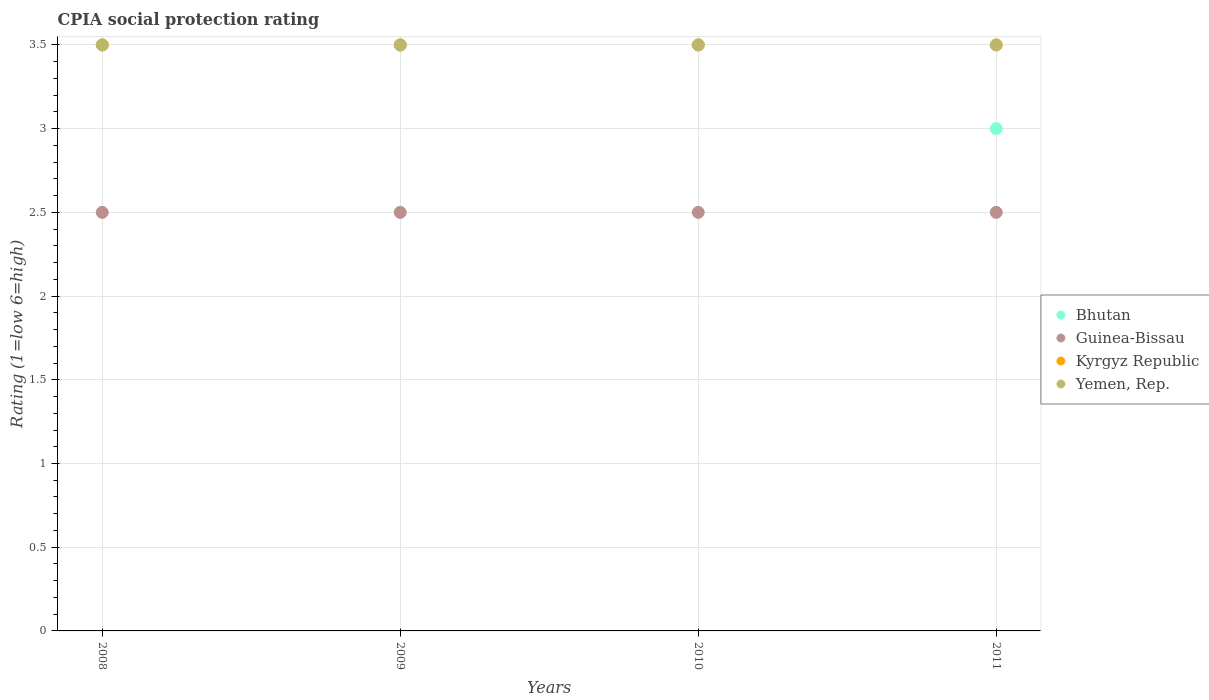How many different coloured dotlines are there?
Ensure brevity in your answer.  4. Is the number of dotlines equal to the number of legend labels?
Your answer should be compact. Yes. What is the CPIA rating in Yemen, Rep. in 2010?
Offer a very short reply. 3.5. Across all years, what is the maximum CPIA rating in Yemen, Rep.?
Your response must be concise. 3.5. In which year was the CPIA rating in Guinea-Bissau maximum?
Your answer should be compact. 2008. In which year was the CPIA rating in Bhutan minimum?
Give a very brief answer. 2011. What is the total CPIA rating in Kyrgyz Republic in the graph?
Offer a very short reply. 14. What is the average CPIA rating in Bhutan per year?
Provide a short and direct response. 3.38. What is the ratio of the CPIA rating in Yemen, Rep. in 2008 to that in 2010?
Offer a very short reply. 1. What is the difference between the highest and the second highest CPIA rating in Yemen, Rep.?
Your answer should be very brief. 0. What is the difference between the highest and the lowest CPIA rating in Yemen, Rep.?
Your response must be concise. 0. Is it the case that in every year, the sum of the CPIA rating in Guinea-Bissau and CPIA rating in Bhutan  is greater than the CPIA rating in Kyrgyz Republic?
Ensure brevity in your answer.  Yes. Does the CPIA rating in Yemen, Rep. monotonically increase over the years?
Offer a very short reply. No. Is the CPIA rating in Guinea-Bissau strictly greater than the CPIA rating in Yemen, Rep. over the years?
Make the answer very short. No. Is the CPIA rating in Bhutan strictly less than the CPIA rating in Guinea-Bissau over the years?
Offer a very short reply. No. How many dotlines are there?
Ensure brevity in your answer.  4. How many years are there in the graph?
Your response must be concise. 4. Does the graph contain any zero values?
Keep it short and to the point. No. Does the graph contain grids?
Make the answer very short. Yes. How many legend labels are there?
Make the answer very short. 4. What is the title of the graph?
Your response must be concise. CPIA social protection rating. What is the label or title of the X-axis?
Your response must be concise. Years. What is the label or title of the Y-axis?
Provide a short and direct response. Rating (1=low 6=high). What is the Rating (1=low 6=high) of Bhutan in 2008?
Offer a very short reply. 3.5. What is the Rating (1=low 6=high) in Bhutan in 2009?
Offer a very short reply. 3.5. What is the Rating (1=low 6=high) of Guinea-Bissau in 2009?
Make the answer very short. 2.5. What is the Rating (1=low 6=high) of Yemen, Rep. in 2009?
Keep it short and to the point. 3.5. What is the Rating (1=low 6=high) of Bhutan in 2010?
Provide a short and direct response. 3.5. What is the Rating (1=low 6=high) of Guinea-Bissau in 2010?
Your answer should be compact. 2.5. What is the Rating (1=low 6=high) of Kyrgyz Republic in 2010?
Ensure brevity in your answer.  3.5. What is the Rating (1=low 6=high) of Bhutan in 2011?
Offer a very short reply. 3. What is the Rating (1=low 6=high) of Yemen, Rep. in 2011?
Offer a very short reply. 3.5. Across all years, what is the maximum Rating (1=low 6=high) of Guinea-Bissau?
Keep it short and to the point. 2.5. Across all years, what is the maximum Rating (1=low 6=high) in Kyrgyz Republic?
Your answer should be compact. 3.5. Across all years, what is the minimum Rating (1=low 6=high) of Kyrgyz Republic?
Your answer should be compact. 3.5. Across all years, what is the minimum Rating (1=low 6=high) of Yemen, Rep.?
Provide a short and direct response. 3.5. What is the total Rating (1=low 6=high) of Bhutan in the graph?
Keep it short and to the point. 13.5. What is the total Rating (1=low 6=high) of Kyrgyz Republic in the graph?
Provide a succinct answer. 14. What is the total Rating (1=low 6=high) of Yemen, Rep. in the graph?
Your answer should be very brief. 14. What is the difference between the Rating (1=low 6=high) in Guinea-Bissau in 2008 and that in 2009?
Provide a succinct answer. 0. What is the difference between the Rating (1=low 6=high) in Yemen, Rep. in 2008 and that in 2009?
Give a very brief answer. 0. What is the difference between the Rating (1=low 6=high) of Guinea-Bissau in 2008 and that in 2010?
Offer a very short reply. 0. What is the difference between the Rating (1=low 6=high) in Kyrgyz Republic in 2008 and that in 2010?
Provide a short and direct response. 0. What is the difference between the Rating (1=low 6=high) in Yemen, Rep. in 2008 and that in 2010?
Offer a very short reply. 0. What is the difference between the Rating (1=low 6=high) of Bhutan in 2008 and that in 2011?
Make the answer very short. 0.5. What is the difference between the Rating (1=low 6=high) in Yemen, Rep. in 2008 and that in 2011?
Provide a succinct answer. 0. What is the difference between the Rating (1=low 6=high) of Guinea-Bissau in 2009 and that in 2010?
Offer a very short reply. 0. What is the difference between the Rating (1=low 6=high) of Kyrgyz Republic in 2009 and that in 2010?
Your response must be concise. 0. What is the difference between the Rating (1=low 6=high) of Yemen, Rep. in 2009 and that in 2010?
Your answer should be very brief. 0. What is the difference between the Rating (1=low 6=high) in Guinea-Bissau in 2009 and that in 2011?
Offer a very short reply. 0. What is the difference between the Rating (1=low 6=high) in Kyrgyz Republic in 2009 and that in 2011?
Your answer should be very brief. 0. What is the difference between the Rating (1=low 6=high) in Bhutan in 2010 and that in 2011?
Your response must be concise. 0.5. What is the difference between the Rating (1=low 6=high) in Guinea-Bissau in 2010 and that in 2011?
Provide a short and direct response. 0. What is the difference between the Rating (1=low 6=high) of Yemen, Rep. in 2010 and that in 2011?
Give a very brief answer. 0. What is the difference between the Rating (1=low 6=high) of Bhutan in 2008 and the Rating (1=low 6=high) of Guinea-Bissau in 2009?
Your answer should be compact. 1. What is the difference between the Rating (1=low 6=high) of Bhutan in 2008 and the Rating (1=low 6=high) of Yemen, Rep. in 2009?
Offer a terse response. 0. What is the difference between the Rating (1=low 6=high) of Guinea-Bissau in 2008 and the Rating (1=low 6=high) of Kyrgyz Republic in 2009?
Make the answer very short. -1. What is the difference between the Rating (1=low 6=high) of Guinea-Bissau in 2008 and the Rating (1=low 6=high) of Yemen, Rep. in 2009?
Ensure brevity in your answer.  -1. What is the difference between the Rating (1=low 6=high) in Kyrgyz Republic in 2008 and the Rating (1=low 6=high) in Yemen, Rep. in 2009?
Provide a succinct answer. 0. What is the difference between the Rating (1=low 6=high) in Bhutan in 2008 and the Rating (1=low 6=high) in Kyrgyz Republic in 2010?
Keep it short and to the point. 0. What is the difference between the Rating (1=low 6=high) in Guinea-Bissau in 2008 and the Rating (1=low 6=high) in Yemen, Rep. in 2010?
Offer a very short reply. -1. What is the difference between the Rating (1=low 6=high) in Kyrgyz Republic in 2008 and the Rating (1=low 6=high) in Yemen, Rep. in 2010?
Ensure brevity in your answer.  0. What is the difference between the Rating (1=low 6=high) of Bhutan in 2008 and the Rating (1=low 6=high) of Yemen, Rep. in 2011?
Give a very brief answer. 0. What is the difference between the Rating (1=low 6=high) of Bhutan in 2009 and the Rating (1=low 6=high) of Guinea-Bissau in 2010?
Make the answer very short. 1. What is the difference between the Rating (1=low 6=high) in Kyrgyz Republic in 2009 and the Rating (1=low 6=high) in Yemen, Rep. in 2010?
Your answer should be compact. 0. What is the difference between the Rating (1=low 6=high) of Bhutan in 2009 and the Rating (1=low 6=high) of Guinea-Bissau in 2011?
Your answer should be very brief. 1. What is the difference between the Rating (1=low 6=high) in Bhutan in 2009 and the Rating (1=low 6=high) in Yemen, Rep. in 2011?
Offer a terse response. 0. What is the difference between the Rating (1=low 6=high) in Kyrgyz Republic in 2009 and the Rating (1=low 6=high) in Yemen, Rep. in 2011?
Your response must be concise. 0. What is the difference between the Rating (1=low 6=high) of Bhutan in 2010 and the Rating (1=low 6=high) of Yemen, Rep. in 2011?
Your answer should be very brief. 0. What is the difference between the Rating (1=low 6=high) of Guinea-Bissau in 2010 and the Rating (1=low 6=high) of Kyrgyz Republic in 2011?
Your answer should be compact. -1. What is the difference between the Rating (1=low 6=high) in Kyrgyz Republic in 2010 and the Rating (1=low 6=high) in Yemen, Rep. in 2011?
Your answer should be compact. 0. What is the average Rating (1=low 6=high) in Bhutan per year?
Offer a terse response. 3.38. What is the average Rating (1=low 6=high) of Guinea-Bissau per year?
Provide a short and direct response. 2.5. What is the average Rating (1=low 6=high) in Yemen, Rep. per year?
Your answer should be compact. 3.5. In the year 2008, what is the difference between the Rating (1=low 6=high) in Bhutan and Rating (1=low 6=high) in Guinea-Bissau?
Ensure brevity in your answer.  1. In the year 2008, what is the difference between the Rating (1=low 6=high) of Bhutan and Rating (1=low 6=high) of Yemen, Rep.?
Keep it short and to the point. 0. In the year 2008, what is the difference between the Rating (1=low 6=high) of Guinea-Bissau and Rating (1=low 6=high) of Yemen, Rep.?
Your answer should be very brief. -1. In the year 2009, what is the difference between the Rating (1=low 6=high) of Bhutan and Rating (1=low 6=high) of Guinea-Bissau?
Ensure brevity in your answer.  1. In the year 2009, what is the difference between the Rating (1=low 6=high) in Bhutan and Rating (1=low 6=high) in Yemen, Rep.?
Provide a short and direct response. 0. In the year 2009, what is the difference between the Rating (1=low 6=high) in Guinea-Bissau and Rating (1=low 6=high) in Kyrgyz Republic?
Ensure brevity in your answer.  -1. In the year 2009, what is the difference between the Rating (1=low 6=high) of Guinea-Bissau and Rating (1=low 6=high) of Yemen, Rep.?
Provide a short and direct response. -1. In the year 2009, what is the difference between the Rating (1=low 6=high) of Kyrgyz Republic and Rating (1=low 6=high) of Yemen, Rep.?
Provide a succinct answer. 0. In the year 2010, what is the difference between the Rating (1=low 6=high) in Guinea-Bissau and Rating (1=low 6=high) in Kyrgyz Republic?
Your response must be concise. -1. In the year 2010, what is the difference between the Rating (1=low 6=high) in Kyrgyz Republic and Rating (1=low 6=high) in Yemen, Rep.?
Ensure brevity in your answer.  0. In the year 2011, what is the difference between the Rating (1=low 6=high) of Bhutan and Rating (1=low 6=high) of Yemen, Rep.?
Your answer should be compact. -0.5. What is the ratio of the Rating (1=low 6=high) in Bhutan in 2008 to that in 2009?
Provide a short and direct response. 1. What is the ratio of the Rating (1=low 6=high) of Kyrgyz Republic in 2008 to that in 2009?
Your answer should be very brief. 1. What is the ratio of the Rating (1=low 6=high) of Bhutan in 2008 to that in 2010?
Ensure brevity in your answer.  1. What is the ratio of the Rating (1=low 6=high) of Yemen, Rep. in 2008 to that in 2010?
Offer a very short reply. 1. What is the ratio of the Rating (1=low 6=high) in Guinea-Bissau in 2008 to that in 2011?
Provide a succinct answer. 1. What is the ratio of the Rating (1=low 6=high) of Kyrgyz Republic in 2008 to that in 2011?
Provide a short and direct response. 1. What is the ratio of the Rating (1=low 6=high) of Kyrgyz Republic in 2009 to that in 2010?
Keep it short and to the point. 1. What is the ratio of the Rating (1=low 6=high) of Yemen, Rep. in 2009 to that in 2010?
Offer a very short reply. 1. What is the ratio of the Rating (1=low 6=high) in Bhutan in 2009 to that in 2011?
Your answer should be very brief. 1.17. What is the ratio of the Rating (1=low 6=high) of Guinea-Bissau in 2009 to that in 2011?
Ensure brevity in your answer.  1. What is the ratio of the Rating (1=low 6=high) of Yemen, Rep. in 2009 to that in 2011?
Provide a succinct answer. 1. What is the ratio of the Rating (1=low 6=high) in Bhutan in 2010 to that in 2011?
Ensure brevity in your answer.  1.17. What is the ratio of the Rating (1=low 6=high) of Guinea-Bissau in 2010 to that in 2011?
Offer a very short reply. 1. What is the difference between the highest and the second highest Rating (1=low 6=high) of Bhutan?
Your response must be concise. 0. What is the difference between the highest and the second highest Rating (1=low 6=high) in Guinea-Bissau?
Make the answer very short. 0. What is the difference between the highest and the second highest Rating (1=low 6=high) in Kyrgyz Republic?
Give a very brief answer. 0. What is the difference between the highest and the lowest Rating (1=low 6=high) of Bhutan?
Your response must be concise. 0.5. 